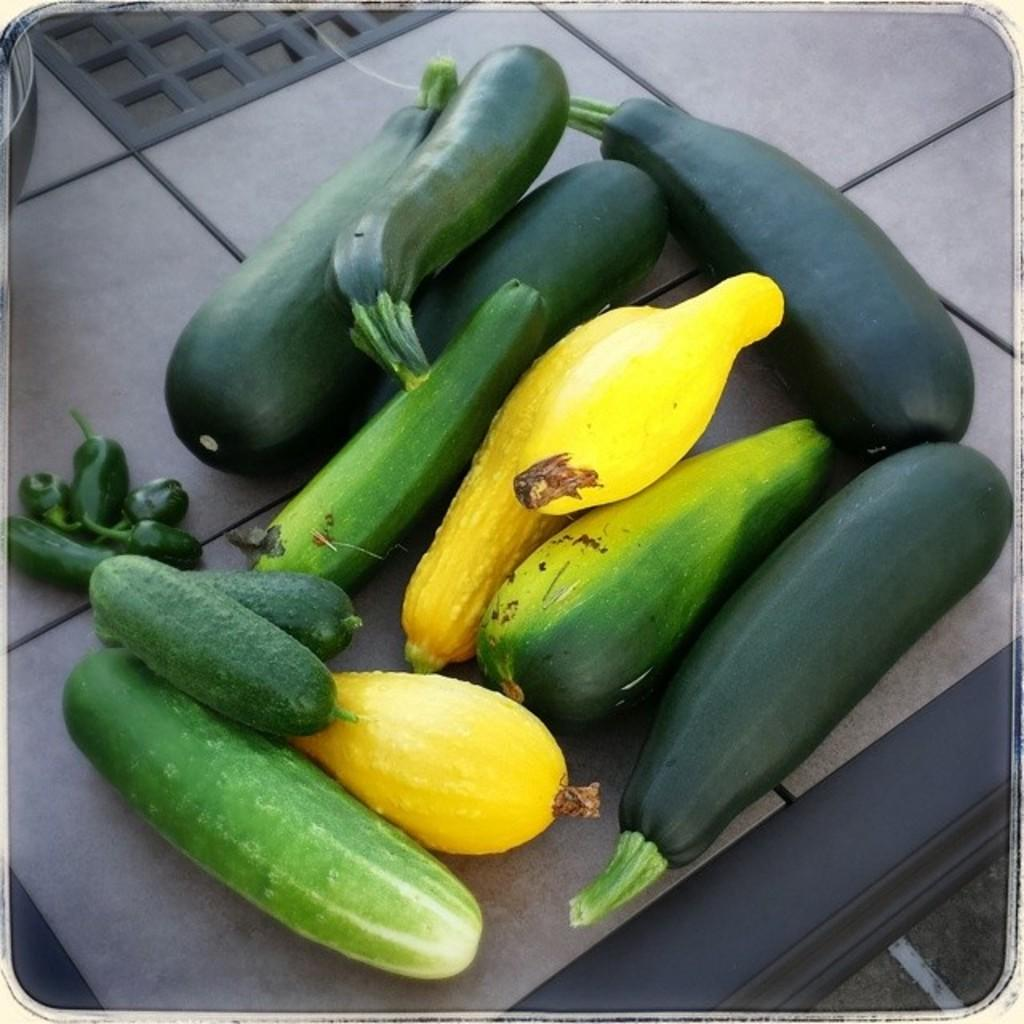What type of furniture is present in the image? There is a table in the image. What items can be seen on the table? There are vegetables on the table. Where is the maid standing in the image? There is no maid present in the image. Can you see a lake in the background of the image? There is no lake visible in the image. 